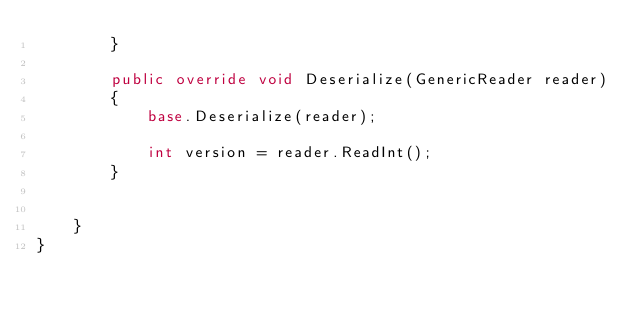<code> <loc_0><loc_0><loc_500><loc_500><_C#_>        }

        public override void Deserialize(GenericReader reader)
        {
            base.Deserialize(reader);

            int version = reader.ReadInt();
        }


    }
}</code> 